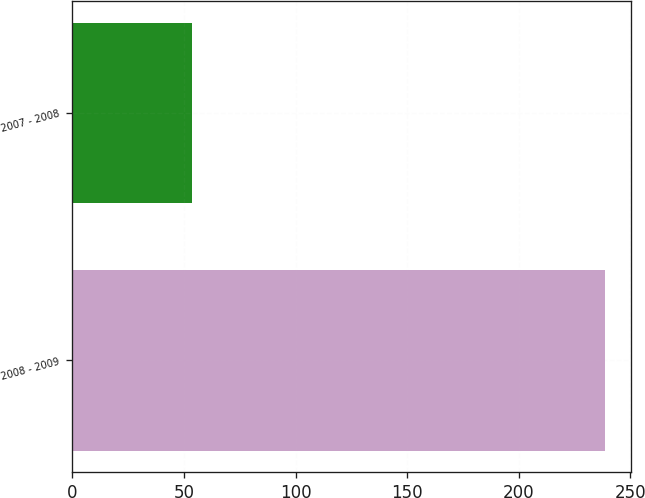<chart> <loc_0><loc_0><loc_500><loc_500><bar_chart><fcel>2008 - 2009<fcel>2007 - 2008<nl><fcel>238.5<fcel>53.7<nl></chart> 